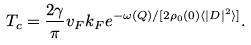Convert formula to latex. <formula><loc_0><loc_0><loc_500><loc_500>T _ { c } = \frac { 2 \gamma } { \pi } v _ { F } k _ { F } e ^ { - \omega ( Q ) / [ 2 \rho _ { 0 } ( 0 ) \langle | D | ^ { 2 } \rangle ] } .</formula> 